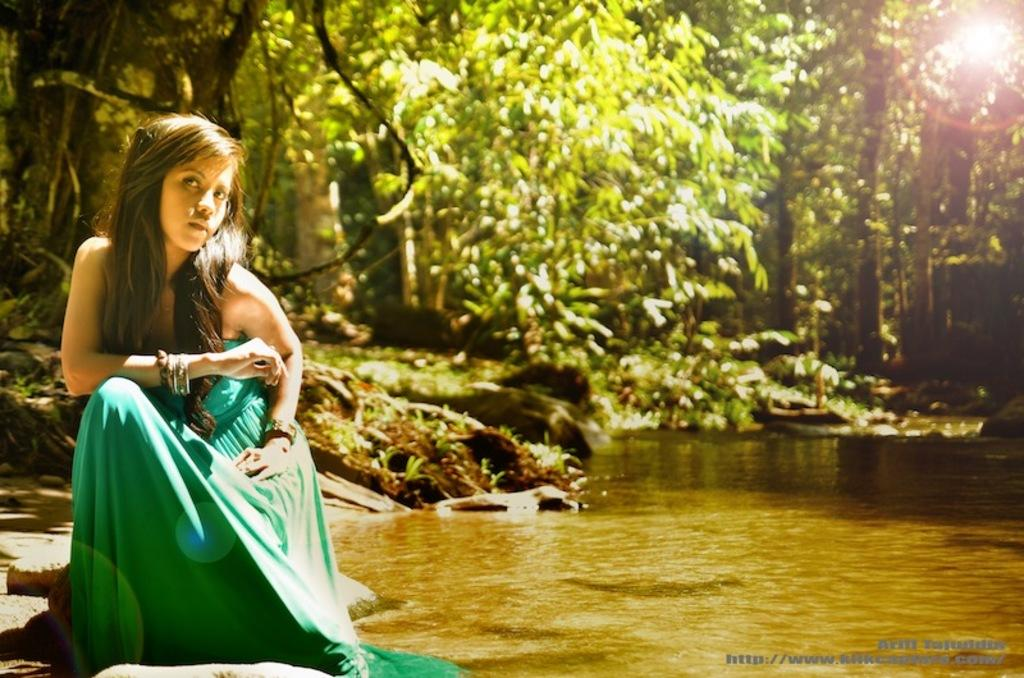Who is present in the image? There is a girl in the image. What is the girl doing in the image? The girl is sitting beside a lake. What can be seen in the background of the image? There are trees visible behind the girl. What type of knee injury does the girl have in the image? There is no indication of a knee injury in the image; the girl is simply sitting beside a lake. 